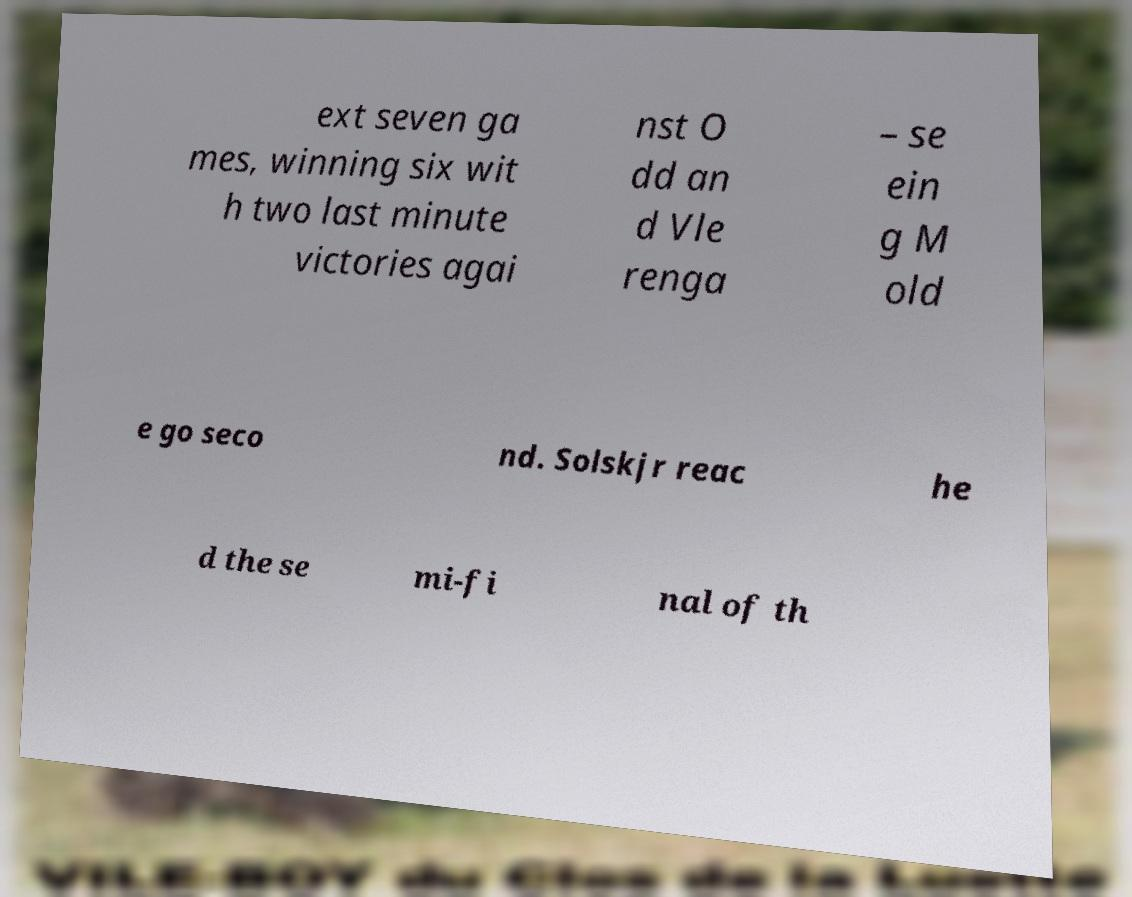Please identify and transcribe the text found in this image. ext seven ga mes, winning six wit h two last minute victories agai nst O dd an d Vle renga – se ein g M old e go seco nd. Solskjr reac he d the se mi-fi nal of th 